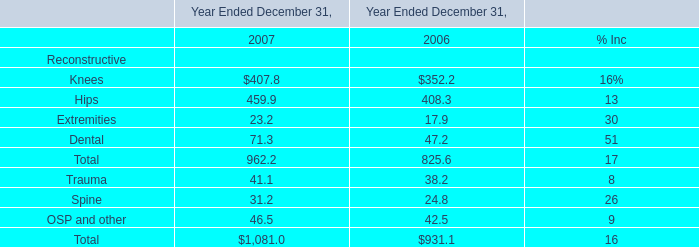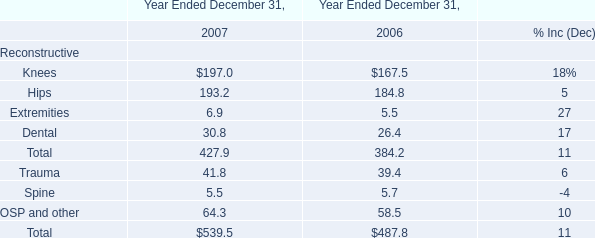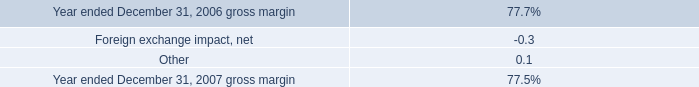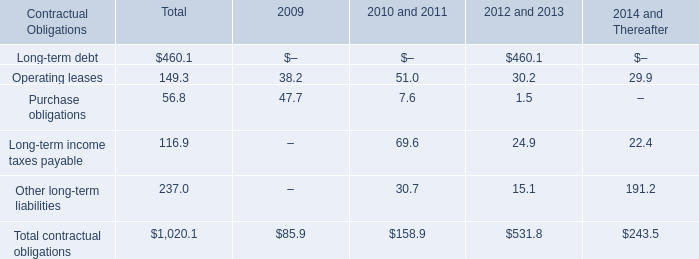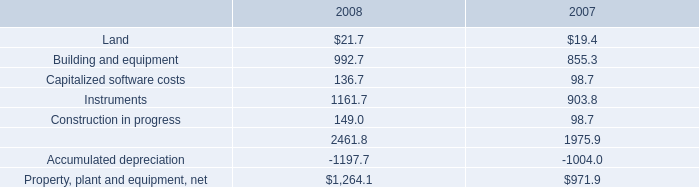What is the proportion of all 2008 that are greater than1000 to the total amount of 2008, in in 2008? 
Computations: ((1161.7 + 2461.8) / 1264.1)
Answer: 2.86647. 